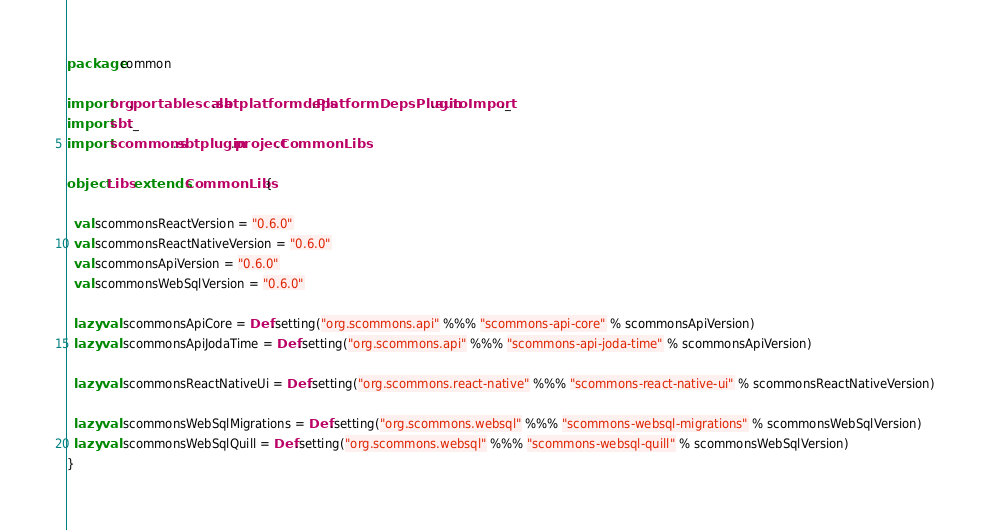<code> <loc_0><loc_0><loc_500><loc_500><_Scala_>package common

import org.portablescala.sbtplatformdeps.PlatformDepsPlugin.autoImport._
import sbt._
import scommons.sbtplugin.project.CommonLibs

object Libs extends CommonLibs {
  
  val scommonsReactVersion = "0.6.0"
  val scommonsReactNativeVersion = "0.6.0"
  val scommonsApiVersion = "0.6.0"
  val scommonsWebSqlVersion = "0.6.0"

  lazy val scommonsApiCore = Def.setting("org.scommons.api" %%% "scommons-api-core" % scommonsApiVersion)
  lazy val scommonsApiJodaTime = Def.setting("org.scommons.api" %%% "scommons-api-joda-time" % scommonsApiVersion)

  lazy val scommonsReactNativeUi = Def.setting("org.scommons.react-native" %%% "scommons-react-native-ui" % scommonsReactNativeVersion)

  lazy val scommonsWebSqlMigrations = Def.setting("org.scommons.websql" %%% "scommons-websql-migrations" % scommonsWebSqlVersion)
  lazy val scommonsWebSqlQuill = Def.setting("org.scommons.websql" %%% "scommons-websql-quill" % scommonsWebSqlVersion)
}
</code> 